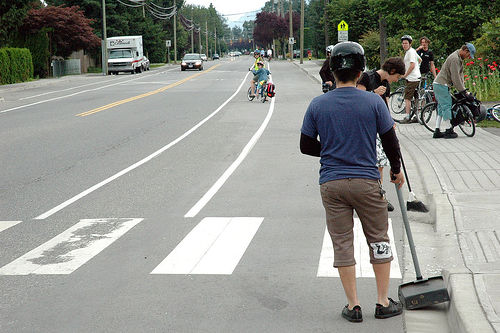<image>
Can you confirm if the vehicle is next to the man? No. The vehicle is not positioned next to the man. They are located in different areas of the scene. Is the human behind the collector? Yes. From this viewpoint, the human is positioned behind the collector, with the collector partially or fully occluding the human. 